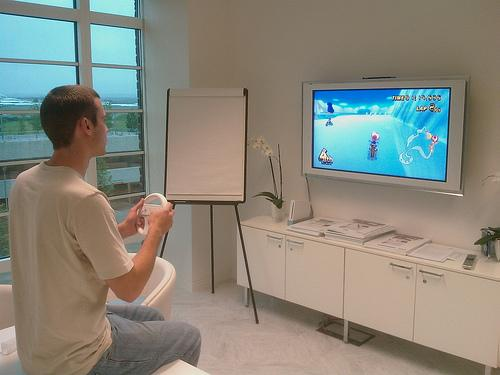For the visual entailment task, describe the connection between the boy and the gray remote control. The boy is controlling the large gray TV using the gray remote control while playing video games. Choose a detail from the image and describe it using an elegant and sophisticated tone. Nestled atop the pristine white surface of the cabinet lies a charming assortment of delicate white and green flowers, bringing an air of elegance and refinement to the surroundings. For the referential expression grounding task, determine the location of the Wii remote in relation to the man. The Wii remote is in the man's hands as he plays a video game. Explain the relationship between the white cabinet and the gray cabinet handle. The gray cabinet handle is attached to the white cabinet. What type of paper-related object is beside the window in the image? There is a large pad of white paper on a black easel beside the window. What kind of controller is the boy holding, and what color is it? The boy is holding a round, white game controller. How would you describe the boy's outfit in the image? The boy is wearing a white shirt and blue jeans. Identify the main activity that the boy is engaged in and mention the object he is holding. The boy is playing a video game and holding a white game controller. List at least two objects found on the cabinets in this image. White and green flowers and stacks of papers can be seen on the cabinets. In the product advertisement task, imagine promoting the TV. Briefly describe its features. Introducing our new large gray TV, designed for the ultimate entertainment experience with its sleek wall-mounted design and 179x179 dimensions, perfect for enjoying your favorite video games and shows. 